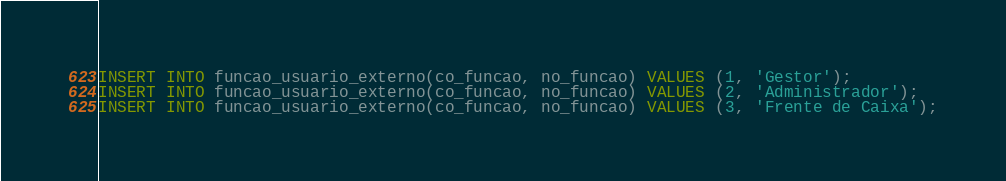Convert code to text. <code><loc_0><loc_0><loc_500><loc_500><_SQL_>INSERT INTO funcao_usuario_externo(co_funcao, no_funcao) VALUES (1, 'Gestor');
INSERT INTO funcao_usuario_externo(co_funcao, no_funcao) VALUES (2, 'Administrador');
INSERT INTO funcao_usuario_externo(co_funcao, no_funcao) VALUES (3, 'Frente de Caixa');</code> 